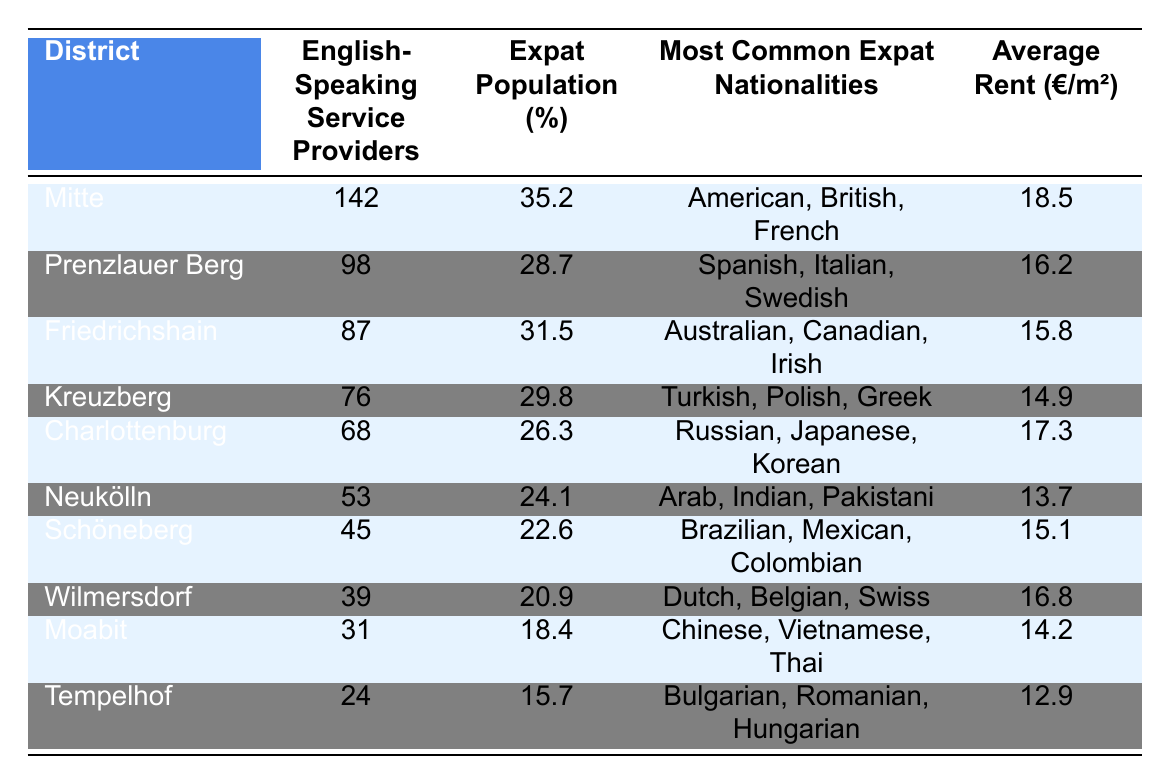What district has the highest number of English-speaking service providers? The district with the highest number of English-speaking service providers is indicated in the table by looking for the largest value in the "English-Speaking Service Providers" column. That is Mitte with 142 providers.
Answer: Mitte Which district has the lowest average rent per square meter? To find the district with the lowest average rent, we look for the smallest value in the "Average Rent (€/m²)" column. That is Tempelhof with an average rent of 12.9 €/m².
Answer: Tempelhof What is the percentage of the expat population in Charlottenburg? The percentage of the expat population in Charlottenburg can be found directly in the table in the corresponding row under the "Expat Population (%)" column, which shows 26.3%.
Answer: 26.3% How many English-speaking service providers are there in Friedrichshain compared to Neukölln? Friedrichshain has 87 English-speaking service providers (as per the table) while Neukölln has 53. The difference is 87 - 53 = 34. Therefore, Friedrichshain has 34 more English-speaking service providers than Neukölln.
Answer: 34 Is the expat population percentage in Schöneberg greater than that in Wilmersdorf? For this question, we examine the "Expat Population (%)" column for both Schöneberg (22.6%) and Wilmersdorf (20.9%). Since 22.6% is greater than 20.9%, the assertion is true.
Answer: Yes If we wanted to find the average rent of the top three districts in terms of English-speaking service providers, what would it be? The top three districts by the number of English-speaking service providers are Mitte (18.5 €/m²), Prenzlauer Berg (16.2 €/m²), and Friedrichshain (15.8 €/m²). To find the average, we sum these values: 18.5 + 16.2 + 15.8 = 50.5. Then, we divide by 3, resulting in an average rent of 50.5 / 3 = 16.83 €/m².
Answer: 16.83 What are the most common nationalities among expats in Neukölln? The most common nationalities in Neukölln are found in the "Most Common Expat Nationalities" column, which lists Arab, Indian, and Pakistani as the primary nationalities.
Answer: Arab, Indian, Pakistani Which district has the highest percentage of expats and what is that percentage? By looking at the "Expat Population (%)" column, we identify that Mitte has the highest percentage at 35.2%, making it the district with the most expats.
Answer: 35.2% Name the districts where the average rent is above 15 €/m². To find districts with an average rent above 15 €/m², we check the "Average Rent (€/m²)" column and find that Mitte (18.5), Charlottenburg (17.3), Prenzlauer Berg (16.2), and Wilmersdorf (16.8) meet this criterion.
Answer: Mitte, Prenzlauer Berg, Charlottenburg, Wilmersdorf How many English-speaking service providers are there in Kreuzberg? We can find the number of English-speaking service providers for Kreuzberg directly in the table, where it is shown to be 76.
Answer: 76 Is the common expat nationality in Charlottenburg also found in Friedrichshain? The common expat nationalities listed for both districts are Russian, Japanese, Korean for Charlottenburg, and Australian, Canadian, Irish for Friedrichshain. Since none of these nationalities overlap, the answer is no.
Answer: No 